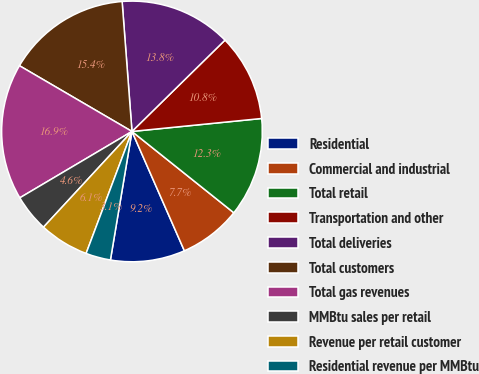Convert chart to OTSL. <chart><loc_0><loc_0><loc_500><loc_500><pie_chart><fcel>Residential<fcel>Commercial and industrial<fcel>Total retail<fcel>Transportation and other<fcel>Total deliveries<fcel>Total customers<fcel>Total gas revenues<fcel>MMBtu sales per retail<fcel>Revenue per retail customer<fcel>Residential revenue per MMBtu<nl><fcel>9.23%<fcel>7.69%<fcel>12.31%<fcel>10.77%<fcel>13.85%<fcel>15.38%<fcel>16.92%<fcel>4.62%<fcel>6.15%<fcel>3.08%<nl></chart> 